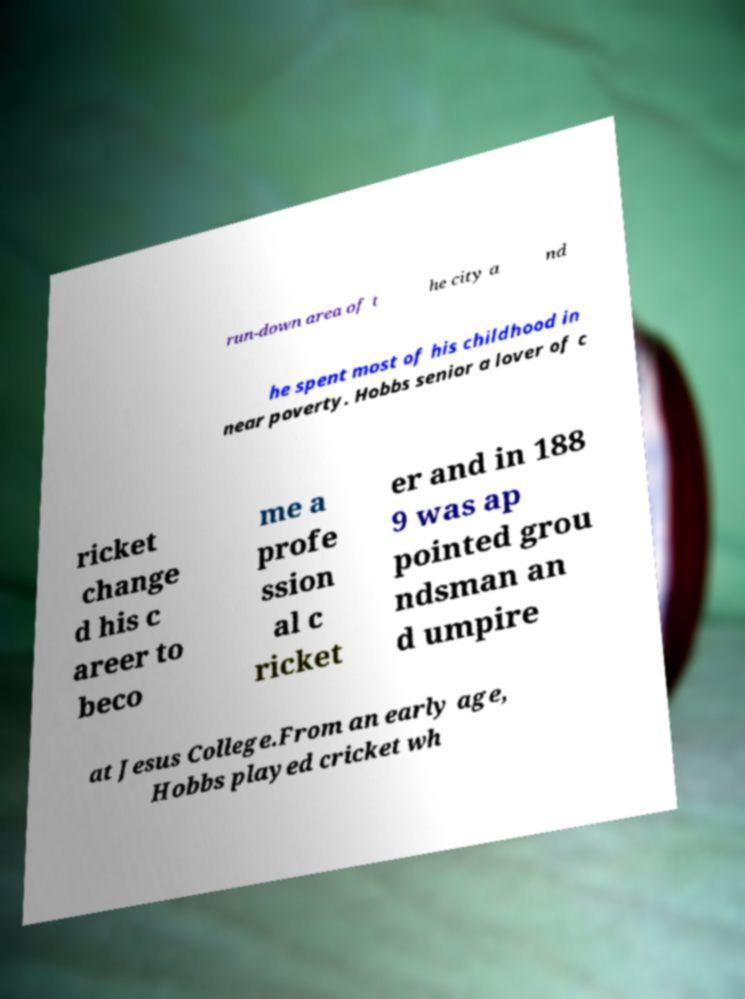There's text embedded in this image that I need extracted. Can you transcribe it verbatim? run-down area of t he city a nd he spent most of his childhood in near poverty. Hobbs senior a lover of c ricket change d his c areer to beco me a profe ssion al c ricket er and in 188 9 was ap pointed grou ndsman an d umpire at Jesus College.From an early age, Hobbs played cricket wh 